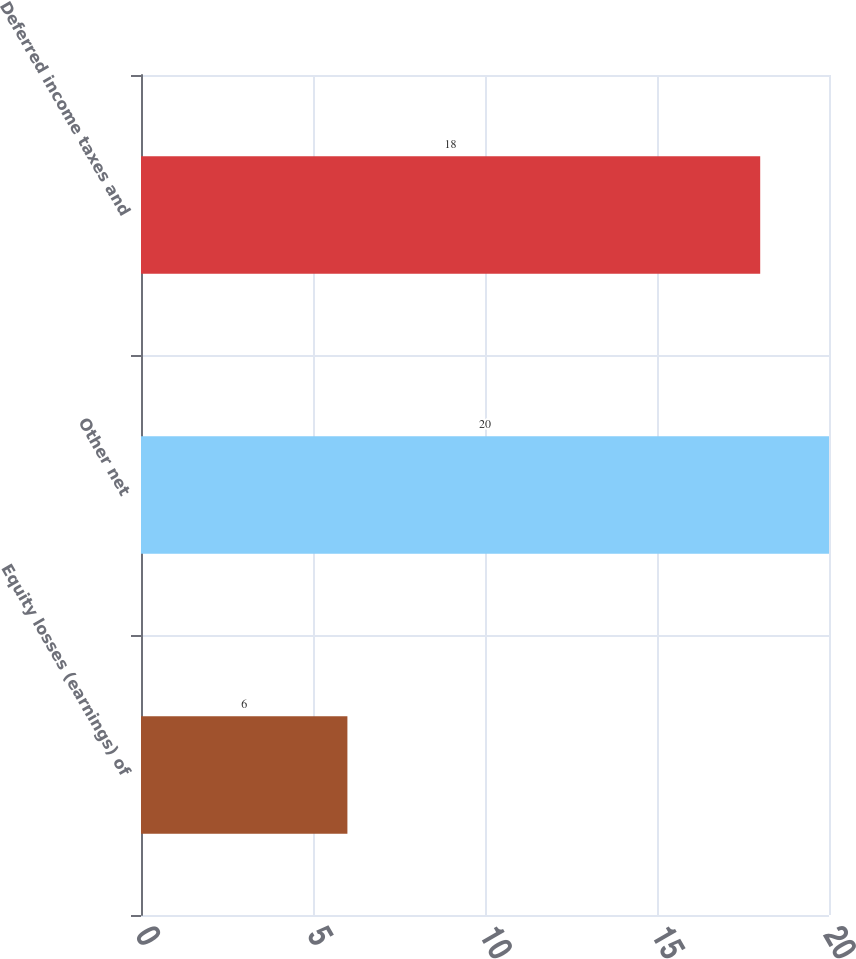Convert chart. <chart><loc_0><loc_0><loc_500><loc_500><bar_chart><fcel>Equity losses (earnings) of<fcel>Other net<fcel>Deferred income taxes and<nl><fcel>6<fcel>20<fcel>18<nl></chart> 